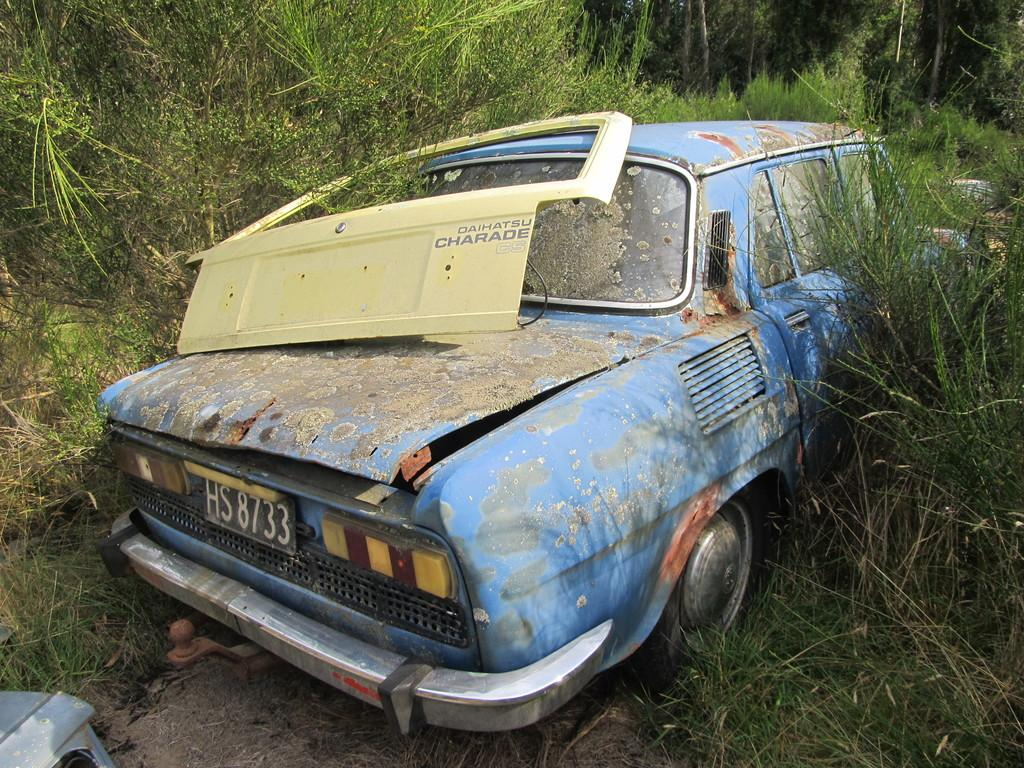What is there is a car in the picture, can you describe it? Yes, there is a car in the picture. What can be seen behind the car in the image? There are trees behind the car in the picture. What is the governor doing in the picture? There is no governor present in the picture, so it is not possible to answer that question. 